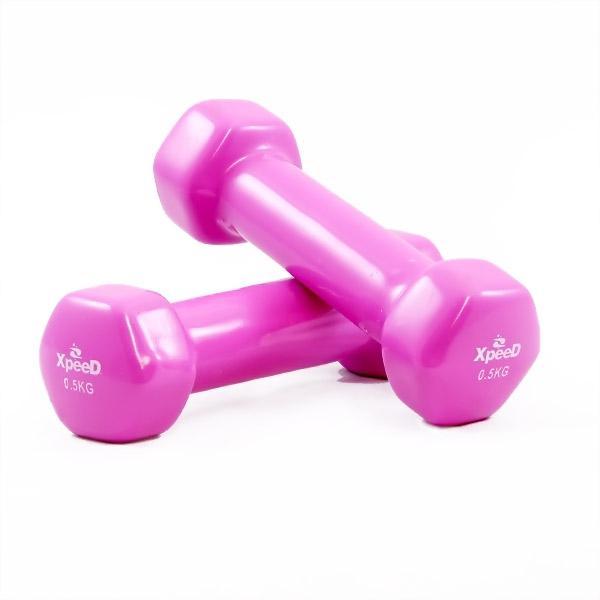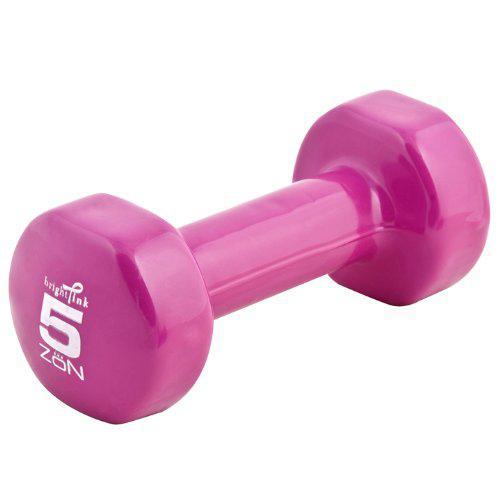The first image is the image on the left, the second image is the image on the right. For the images displayed, is the sentence "In each image, one dumbbell is leaning against another." factually correct? Answer yes or no. No. The first image is the image on the left, the second image is the image on the right. For the images shown, is this caption "There are four dumbbells." true? Answer yes or no. No. 